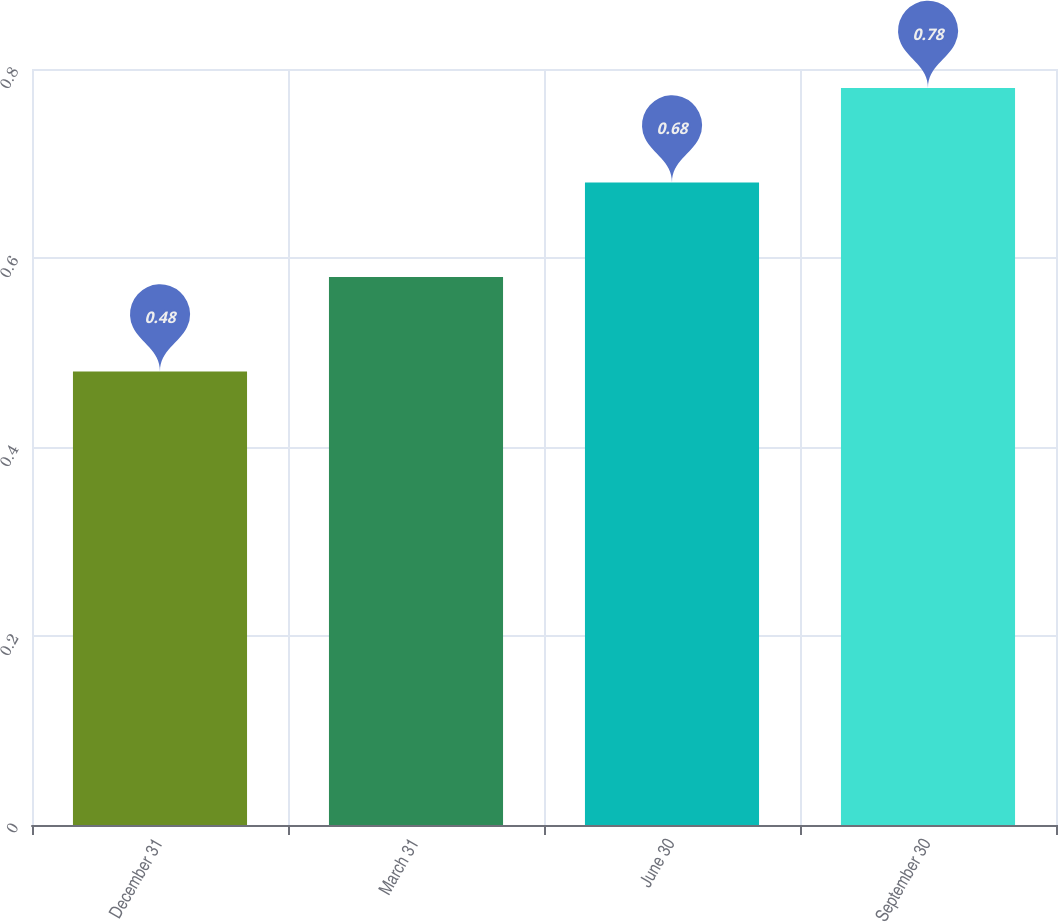<chart> <loc_0><loc_0><loc_500><loc_500><bar_chart><fcel>December 31<fcel>March 31<fcel>June 30<fcel>September 30<nl><fcel>0.48<fcel>0.58<fcel>0.68<fcel>0.78<nl></chart> 